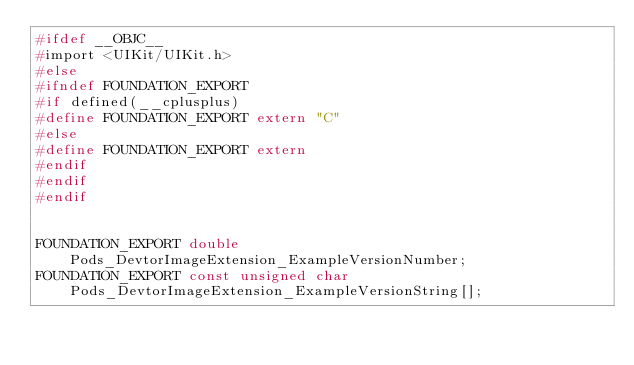Convert code to text. <code><loc_0><loc_0><loc_500><loc_500><_C_>#ifdef __OBJC__
#import <UIKit/UIKit.h>
#else
#ifndef FOUNDATION_EXPORT
#if defined(__cplusplus)
#define FOUNDATION_EXPORT extern "C"
#else
#define FOUNDATION_EXPORT extern
#endif
#endif
#endif


FOUNDATION_EXPORT double Pods_DevtorImageExtension_ExampleVersionNumber;
FOUNDATION_EXPORT const unsigned char Pods_DevtorImageExtension_ExampleVersionString[];

</code> 